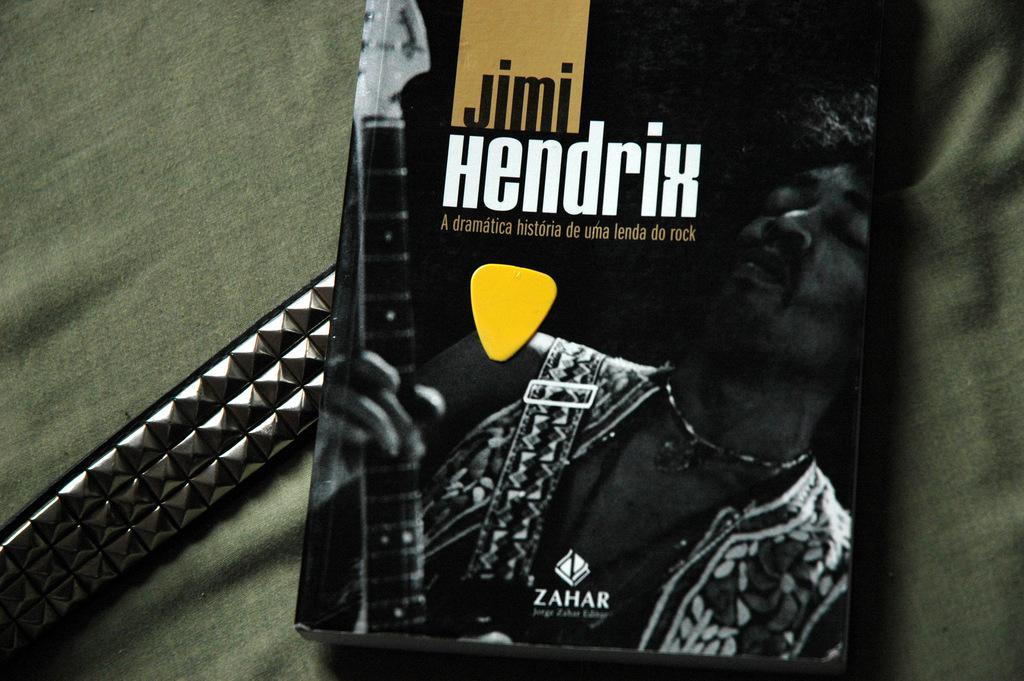<image>
Offer a succinct explanation of the picture presented. A Jimi Hendrix guitar book with a pick on it is laying on a metallic belt and all of it on a green fabric. 